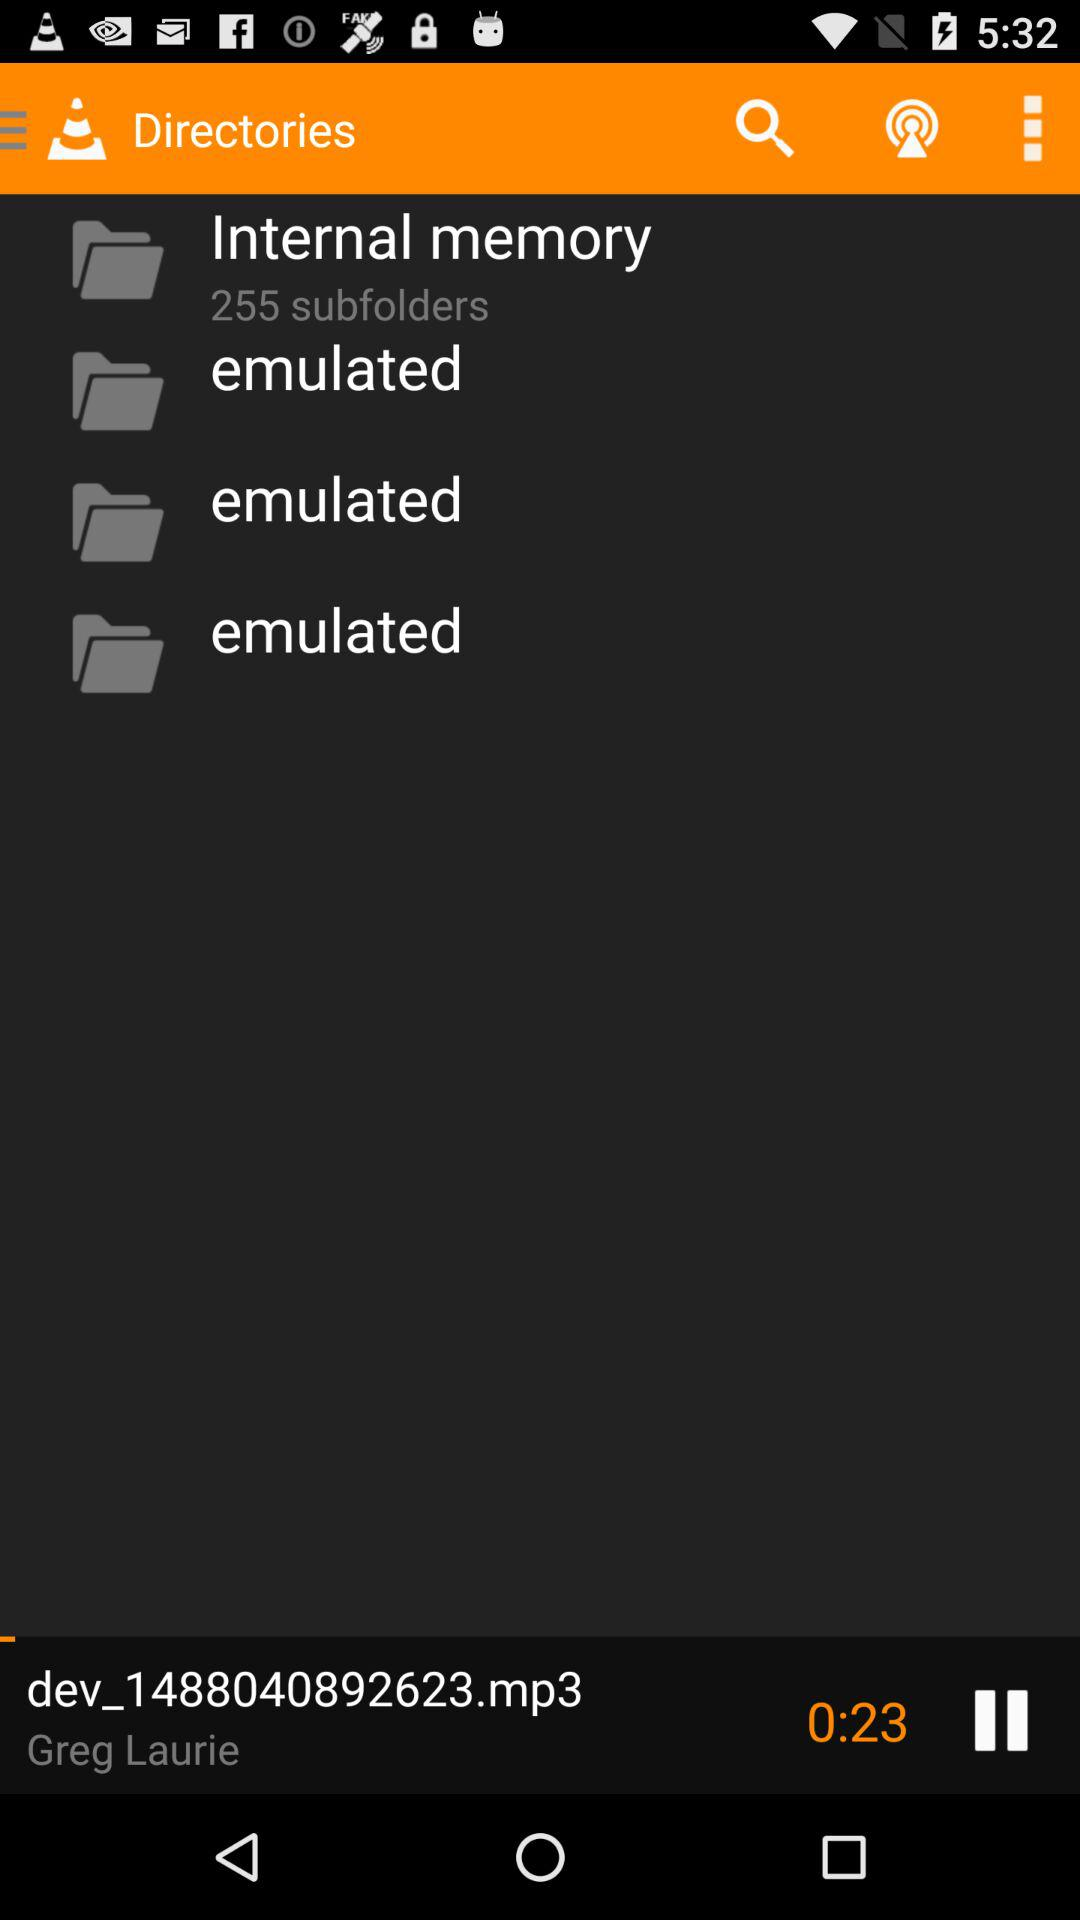What is the duration of the playing audio? The duration is 23 seconds. 